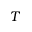<formula> <loc_0><loc_0><loc_500><loc_500>T</formula> 